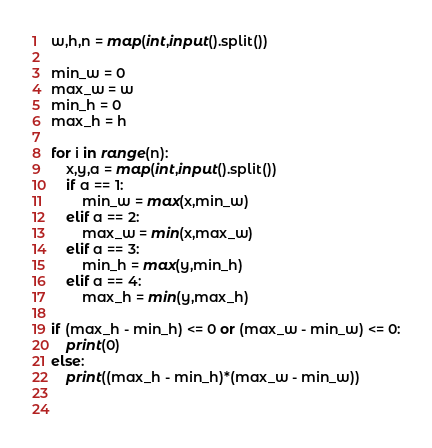<code> <loc_0><loc_0><loc_500><loc_500><_Python_>w,h,n = map(int,input().split())

min_w = 0
max_w = w
min_h = 0
max_h = h

for i in range(n):
    x,y,a = map(int,input().split())
    if a == 1:
        min_w = max(x,min_w)
    elif a == 2:
        max_w = min(x,max_w)
    elif a == 3:
        min_h = max(y,min_h)
    elif a == 4:
        max_h = min(y,max_h)

if (max_h - min_h) <= 0 or (max_w - min_w) <= 0:
    print(0)
else:
    print((max_h - min_h)*(max_w - min_w))

    
</code> 